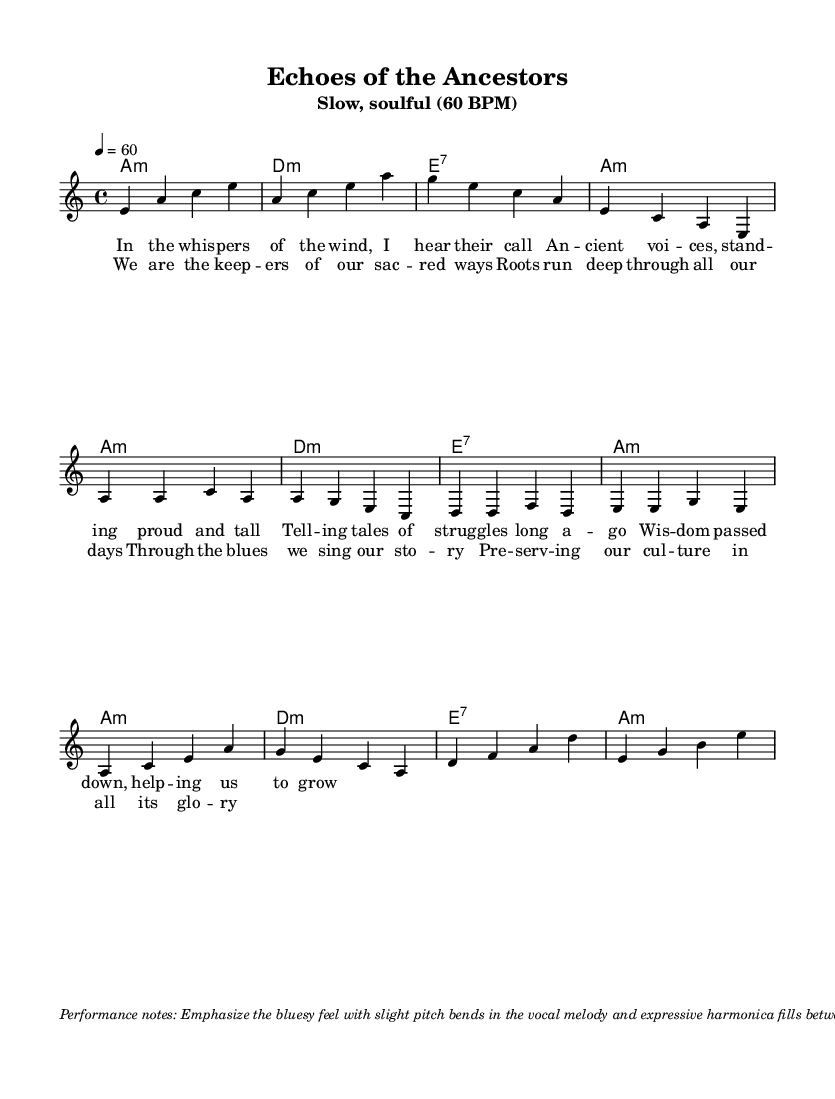What is the key signature of this music? The key signature shows "a minor," which correlates with the notes and chords used throughout the piece, indicating that there are no sharps or flats.
Answer: A minor What is the time signature of this music? The time signature appears at the beginning of the piece and is shown as "4/4," meaning there are four beats per measure.
Answer: 4/4 What is the tempo of this music? The tempo is indicated at the start of the score, showing that it is set to 60 beats per minute, which denotes a slow, soulful feel.
Answer: 60 BPM How many measures are in the verse? By counting the measures labeled for the verse section in the melody, there are a total of four measures, showing the structure of the verse.
Answer: 4 What is the main theme expressed in the chorus? The chorus emphasizes themes of cultural preservation and resilience, as illustrated by the lyrics speaking about being "the keepers of our sacred ways."
Answer: Cultural preservation What type of harmonies are used throughout the piece? The harmonies are based on minor chords and a seventh chord, which is characteristic of the blues genre, enhancing the emotional essence of the song.
Answer: Minor and seventh chords How would you describe the style of the melody? The melody's description in the performance notes suggests a "bluesy feel" with pitch bends, typical for blues music, indicating emotional expression.
Answer: Bluesy feel 